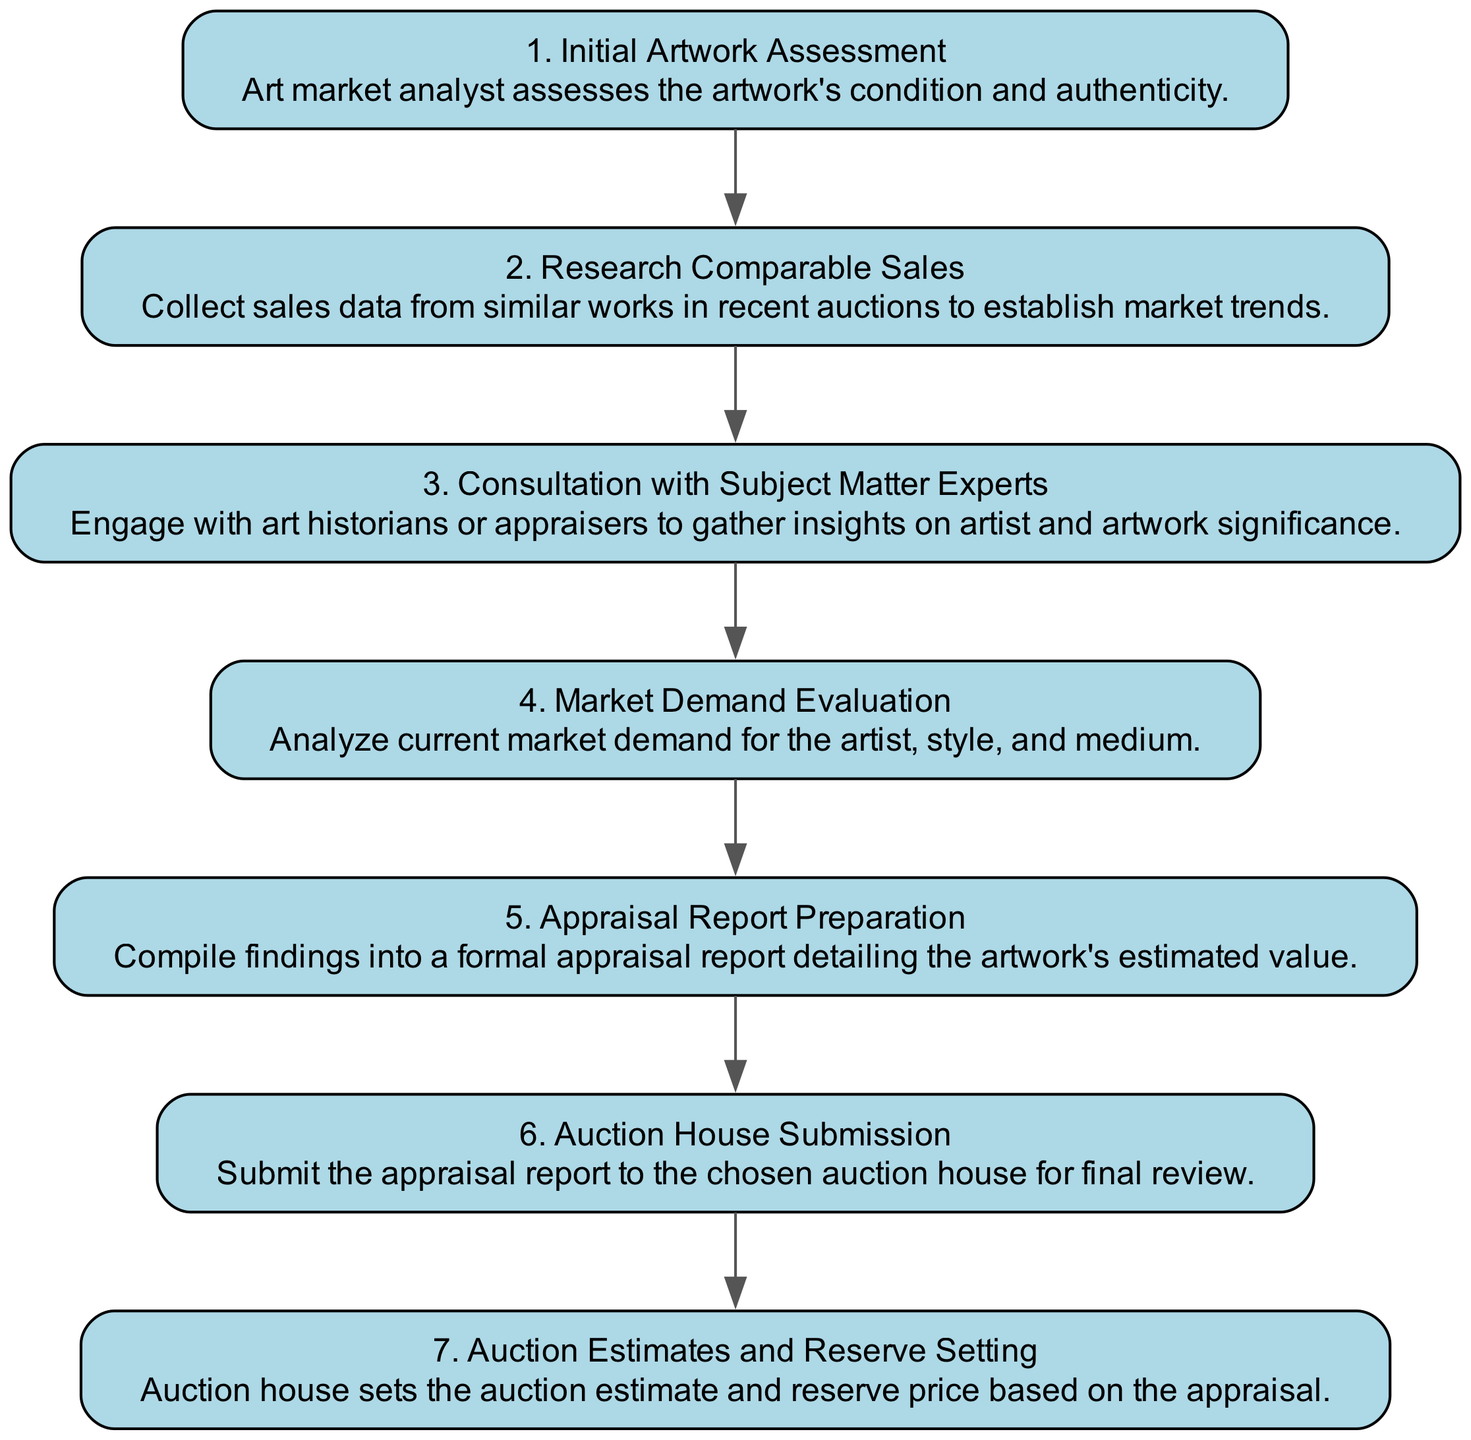What is the first step in the diagram? The first step listed in the diagram is "Initial Artwork Assessment," as it is the starting point of the sequence.
Answer: Initial Artwork Assessment How many steps are involved in the appraisal process? Counting the steps provided in the diagram, there are a total of seven distinct steps in the artwork valuation and appraisal process.
Answer: 7 What is the last step before auction estimates are set? The last step before setting auction estimates is "Auction House Submission," as it directly precedes the auction house's actions of setting estimates.
Answer: Auction House Submission Which step involves engaging with experts? The step "Consultation with Subject Matter Experts" specifically notes the engagement with experts to gather additional insights.
Answer: Consultation with Subject Matter Experts What are the steps taken before the appraisal report preparation? The steps leading to "Appraisal Report Preparation" are "Market Demand Evaluation" and "Consultation with Subject Matter Experts," as they both inform the appraisal process before culminating in the report.
Answer: Market Demand Evaluation, Consultation with Subject Matter Experts What step directly follows "Research Comparable Sales"? The step that directly follows "Research Comparable Sales" is "Consultation with Subject Matter Experts," indicating the progression from market data analysis to expert consultation.
Answer: Consultation with Subject Matter Experts How does the auction house utilize the appraisal report? The auction house utilizes the appraisal report to set auction estimates and reserve prices, as indicated by the sequence that connects these steps.
Answer: Auction Estimates and Reserve Setting 